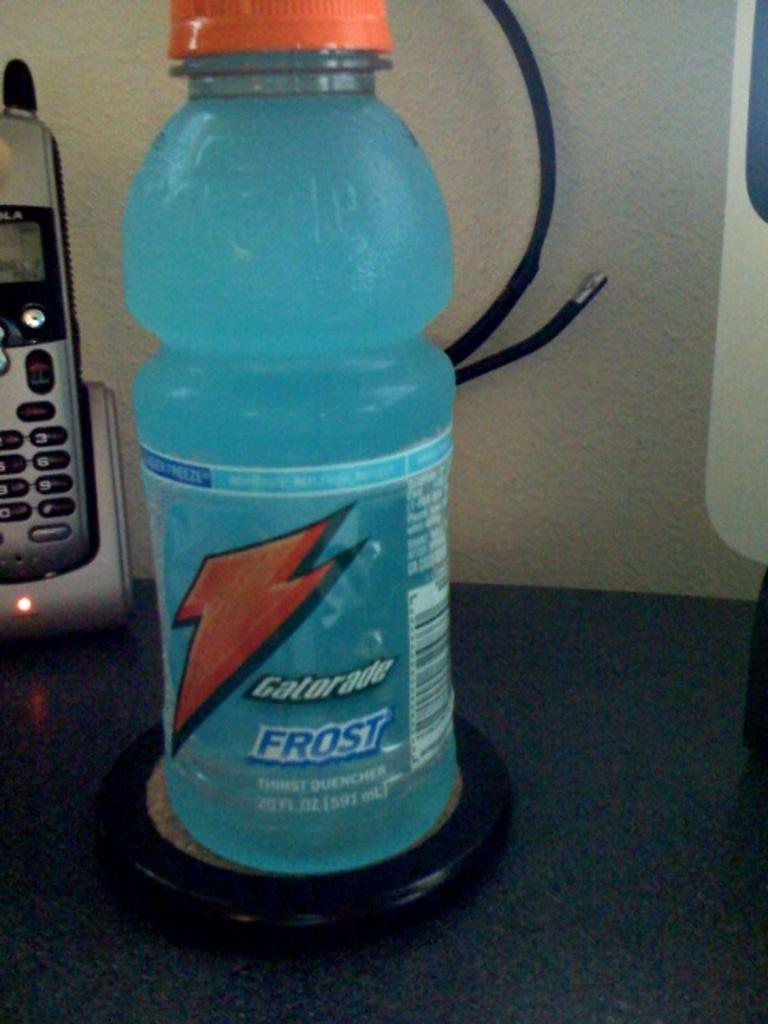What is on the table in the image? There is a juice bottle and a mobile on the table in the image. What color is the cap of the juice bottle? The cap of the juice bottle is orange. What feature does the mobile have? The mobile has a holder. What type of sand can be seen falling from the mobile in the image? There is no sand present in the image, and the mobile does not appear to be releasing any sand. 